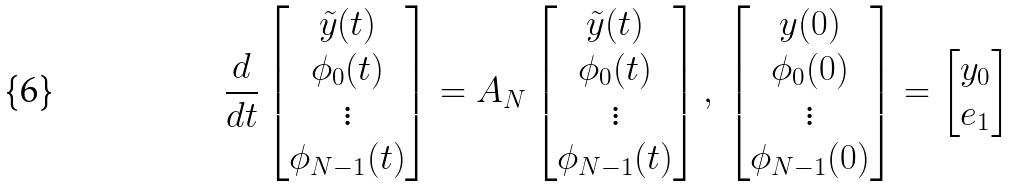Convert formula to latex. <formula><loc_0><loc_0><loc_500><loc_500>\frac { d } { d t } \begin{bmatrix} \tilde { y } ( t ) \\ \phi _ { 0 } ( t ) \\ \vdots \\ \phi _ { N - 1 } ( t ) \\ \end{bmatrix} = A _ { N } \begin{bmatrix} \tilde { y } ( t ) \\ \phi _ { 0 } ( t ) \\ \vdots \\ \phi _ { N - 1 } ( t ) \\ \end{bmatrix} , \, \begin{bmatrix} y ( 0 ) \\ \phi _ { 0 } ( 0 ) \\ \vdots \\ \phi _ { N - 1 } ( 0 ) \\ \end{bmatrix} = \begin{bmatrix} y _ { 0 } \\ e _ { 1 } \end{bmatrix}</formula> 